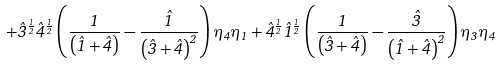Convert formula to latex. <formula><loc_0><loc_0><loc_500><loc_500>+ \hat { 3 } ^ { \frac { 1 } { 2 } } \hat { 4 } ^ { \frac { 1 } { 2 } } \left ( \frac { 1 } { \left ( \hat { 1 } + \hat { 4 } \right ) } - \frac { \hat { 1 } } { \left ( \hat { 3 } + \hat { 4 } \right ) ^ { 2 } } \right ) \eta _ { 4 } \eta _ { 1 } + \hat { 4 } ^ { \frac { 1 } { 2 } } \hat { 1 } ^ { \frac { 1 } { 2 } } \left ( \frac { 1 } { \left ( \hat { 3 } + \hat { 4 } \right ) } - \frac { \hat { 3 } } { \left ( \hat { 1 } + \hat { 4 } \right ) ^ { 2 } } \right ) \eta _ { 3 } \eta _ { 4 }</formula> 